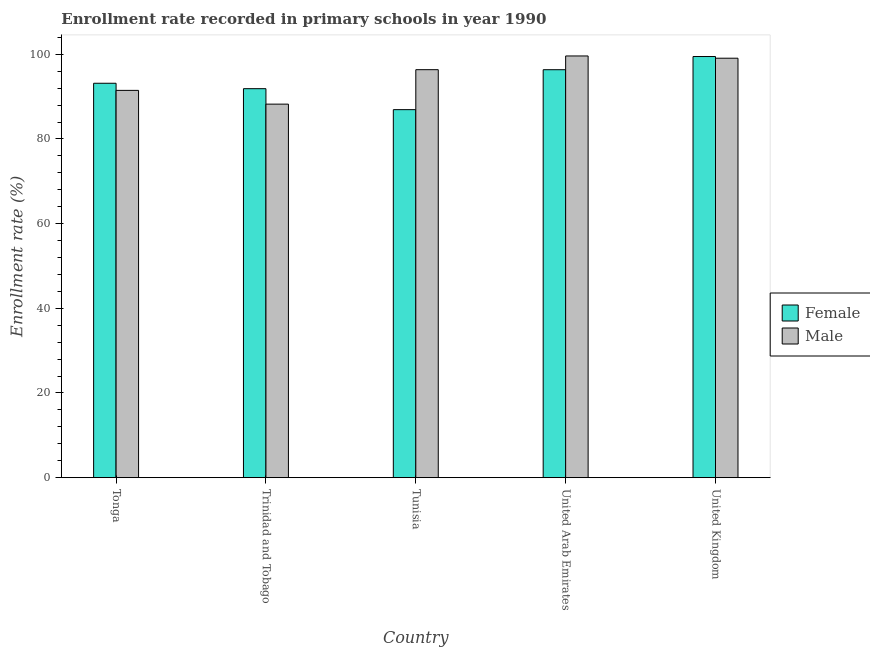How many different coloured bars are there?
Your answer should be very brief. 2. How many groups of bars are there?
Make the answer very short. 5. Are the number of bars per tick equal to the number of legend labels?
Offer a terse response. Yes. Are the number of bars on each tick of the X-axis equal?
Keep it short and to the point. Yes. How many bars are there on the 4th tick from the left?
Offer a very short reply. 2. What is the label of the 3rd group of bars from the left?
Provide a short and direct response. Tunisia. What is the enrollment rate of male students in Trinidad and Tobago?
Provide a succinct answer. 88.24. Across all countries, what is the maximum enrollment rate of male students?
Keep it short and to the point. 99.62. Across all countries, what is the minimum enrollment rate of female students?
Offer a terse response. 86.93. In which country was the enrollment rate of female students maximum?
Your response must be concise. United Kingdom. In which country was the enrollment rate of female students minimum?
Your answer should be compact. Tunisia. What is the total enrollment rate of female students in the graph?
Your response must be concise. 467.84. What is the difference between the enrollment rate of male students in Trinidad and Tobago and that in Tunisia?
Your response must be concise. -8.14. What is the difference between the enrollment rate of male students in United Arab Emirates and the enrollment rate of female students in Trinidad and Tobago?
Keep it short and to the point. 7.73. What is the average enrollment rate of male students per country?
Ensure brevity in your answer.  94.96. What is the difference between the enrollment rate of female students and enrollment rate of male students in Tunisia?
Your answer should be compact. -9.44. What is the ratio of the enrollment rate of male students in Tunisia to that in United Kingdom?
Offer a terse response. 0.97. What is the difference between the highest and the second highest enrollment rate of female students?
Provide a short and direct response. 3.12. What is the difference between the highest and the lowest enrollment rate of female students?
Your answer should be very brief. 12.55. What does the 2nd bar from the right in United Arab Emirates represents?
Your response must be concise. Female. How many bars are there?
Make the answer very short. 10. Are all the bars in the graph horizontal?
Offer a terse response. No. Are the values on the major ticks of Y-axis written in scientific E-notation?
Your answer should be compact. No. Does the graph contain grids?
Ensure brevity in your answer.  No. What is the title of the graph?
Make the answer very short. Enrollment rate recorded in primary schools in year 1990. What is the label or title of the X-axis?
Keep it short and to the point. Country. What is the label or title of the Y-axis?
Your response must be concise. Enrollment rate (%). What is the Enrollment rate (%) in Female in Tonga?
Your answer should be very brief. 93.17. What is the Enrollment rate (%) of Male in Tonga?
Give a very brief answer. 91.48. What is the Enrollment rate (%) of Female in Trinidad and Tobago?
Offer a terse response. 91.89. What is the Enrollment rate (%) of Male in Trinidad and Tobago?
Offer a very short reply. 88.24. What is the Enrollment rate (%) in Female in Tunisia?
Your answer should be compact. 86.93. What is the Enrollment rate (%) of Male in Tunisia?
Your response must be concise. 96.37. What is the Enrollment rate (%) in Female in United Arab Emirates?
Keep it short and to the point. 96.37. What is the Enrollment rate (%) of Male in United Arab Emirates?
Your answer should be very brief. 99.62. What is the Enrollment rate (%) in Female in United Kingdom?
Offer a very short reply. 99.48. What is the Enrollment rate (%) in Male in United Kingdom?
Give a very brief answer. 99.08. Across all countries, what is the maximum Enrollment rate (%) in Female?
Your answer should be compact. 99.48. Across all countries, what is the maximum Enrollment rate (%) in Male?
Give a very brief answer. 99.62. Across all countries, what is the minimum Enrollment rate (%) in Female?
Offer a terse response. 86.93. Across all countries, what is the minimum Enrollment rate (%) of Male?
Your answer should be compact. 88.24. What is the total Enrollment rate (%) of Female in the graph?
Your answer should be very brief. 467.83. What is the total Enrollment rate (%) in Male in the graph?
Your answer should be very brief. 474.79. What is the difference between the Enrollment rate (%) in Female in Tonga and that in Trinidad and Tobago?
Your response must be concise. 1.28. What is the difference between the Enrollment rate (%) in Male in Tonga and that in Trinidad and Tobago?
Keep it short and to the point. 3.25. What is the difference between the Enrollment rate (%) of Female in Tonga and that in Tunisia?
Give a very brief answer. 6.23. What is the difference between the Enrollment rate (%) in Male in Tonga and that in Tunisia?
Provide a succinct answer. -4.89. What is the difference between the Enrollment rate (%) in Female in Tonga and that in United Arab Emirates?
Provide a succinct answer. -3.2. What is the difference between the Enrollment rate (%) in Male in Tonga and that in United Arab Emirates?
Your response must be concise. -8.13. What is the difference between the Enrollment rate (%) in Female in Tonga and that in United Kingdom?
Provide a succinct answer. -6.32. What is the difference between the Enrollment rate (%) in Male in Tonga and that in United Kingdom?
Your answer should be very brief. -7.6. What is the difference between the Enrollment rate (%) of Female in Trinidad and Tobago and that in Tunisia?
Your response must be concise. 4.95. What is the difference between the Enrollment rate (%) in Male in Trinidad and Tobago and that in Tunisia?
Give a very brief answer. -8.14. What is the difference between the Enrollment rate (%) of Female in Trinidad and Tobago and that in United Arab Emirates?
Offer a terse response. -4.48. What is the difference between the Enrollment rate (%) in Male in Trinidad and Tobago and that in United Arab Emirates?
Your response must be concise. -11.38. What is the difference between the Enrollment rate (%) in Female in Trinidad and Tobago and that in United Kingdom?
Ensure brevity in your answer.  -7.6. What is the difference between the Enrollment rate (%) of Male in Trinidad and Tobago and that in United Kingdom?
Offer a very short reply. -10.85. What is the difference between the Enrollment rate (%) of Female in Tunisia and that in United Arab Emirates?
Your response must be concise. -9.44. What is the difference between the Enrollment rate (%) of Male in Tunisia and that in United Arab Emirates?
Your answer should be very brief. -3.24. What is the difference between the Enrollment rate (%) of Female in Tunisia and that in United Kingdom?
Give a very brief answer. -12.55. What is the difference between the Enrollment rate (%) of Male in Tunisia and that in United Kingdom?
Ensure brevity in your answer.  -2.71. What is the difference between the Enrollment rate (%) in Female in United Arab Emirates and that in United Kingdom?
Offer a terse response. -3.12. What is the difference between the Enrollment rate (%) in Male in United Arab Emirates and that in United Kingdom?
Your answer should be very brief. 0.53. What is the difference between the Enrollment rate (%) in Female in Tonga and the Enrollment rate (%) in Male in Trinidad and Tobago?
Provide a short and direct response. 4.93. What is the difference between the Enrollment rate (%) in Female in Tonga and the Enrollment rate (%) in Male in Tunisia?
Provide a succinct answer. -3.21. What is the difference between the Enrollment rate (%) of Female in Tonga and the Enrollment rate (%) of Male in United Arab Emirates?
Ensure brevity in your answer.  -6.45. What is the difference between the Enrollment rate (%) in Female in Tonga and the Enrollment rate (%) in Male in United Kingdom?
Your answer should be compact. -5.92. What is the difference between the Enrollment rate (%) of Female in Trinidad and Tobago and the Enrollment rate (%) of Male in Tunisia?
Your answer should be compact. -4.49. What is the difference between the Enrollment rate (%) of Female in Trinidad and Tobago and the Enrollment rate (%) of Male in United Arab Emirates?
Your answer should be very brief. -7.73. What is the difference between the Enrollment rate (%) of Female in Trinidad and Tobago and the Enrollment rate (%) of Male in United Kingdom?
Make the answer very short. -7.2. What is the difference between the Enrollment rate (%) of Female in Tunisia and the Enrollment rate (%) of Male in United Arab Emirates?
Ensure brevity in your answer.  -12.68. What is the difference between the Enrollment rate (%) of Female in Tunisia and the Enrollment rate (%) of Male in United Kingdom?
Provide a succinct answer. -12.15. What is the difference between the Enrollment rate (%) of Female in United Arab Emirates and the Enrollment rate (%) of Male in United Kingdom?
Provide a short and direct response. -2.72. What is the average Enrollment rate (%) in Female per country?
Offer a terse response. 93.57. What is the average Enrollment rate (%) in Male per country?
Offer a terse response. 94.96. What is the difference between the Enrollment rate (%) in Female and Enrollment rate (%) in Male in Tonga?
Offer a very short reply. 1.68. What is the difference between the Enrollment rate (%) of Female and Enrollment rate (%) of Male in Trinidad and Tobago?
Offer a terse response. 3.65. What is the difference between the Enrollment rate (%) of Female and Enrollment rate (%) of Male in Tunisia?
Your answer should be compact. -9.44. What is the difference between the Enrollment rate (%) of Female and Enrollment rate (%) of Male in United Arab Emirates?
Make the answer very short. -3.25. What is the difference between the Enrollment rate (%) in Female and Enrollment rate (%) in Male in United Kingdom?
Make the answer very short. 0.4. What is the ratio of the Enrollment rate (%) in Female in Tonga to that in Trinidad and Tobago?
Ensure brevity in your answer.  1.01. What is the ratio of the Enrollment rate (%) in Male in Tonga to that in Trinidad and Tobago?
Ensure brevity in your answer.  1.04. What is the ratio of the Enrollment rate (%) in Female in Tonga to that in Tunisia?
Keep it short and to the point. 1.07. What is the ratio of the Enrollment rate (%) of Male in Tonga to that in Tunisia?
Give a very brief answer. 0.95. What is the ratio of the Enrollment rate (%) of Female in Tonga to that in United Arab Emirates?
Offer a very short reply. 0.97. What is the ratio of the Enrollment rate (%) in Male in Tonga to that in United Arab Emirates?
Offer a terse response. 0.92. What is the ratio of the Enrollment rate (%) in Female in Tonga to that in United Kingdom?
Your answer should be compact. 0.94. What is the ratio of the Enrollment rate (%) in Male in Tonga to that in United Kingdom?
Your answer should be very brief. 0.92. What is the ratio of the Enrollment rate (%) of Female in Trinidad and Tobago to that in Tunisia?
Provide a short and direct response. 1.06. What is the ratio of the Enrollment rate (%) of Male in Trinidad and Tobago to that in Tunisia?
Provide a short and direct response. 0.92. What is the ratio of the Enrollment rate (%) in Female in Trinidad and Tobago to that in United Arab Emirates?
Keep it short and to the point. 0.95. What is the ratio of the Enrollment rate (%) of Male in Trinidad and Tobago to that in United Arab Emirates?
Offer a very short reply. 0.89. What is the ratio of the Enrollment rate (%) of Female in Trinidad and Tobago to that in United Kingdom?
Provide a succinct answer. 0.92. What is the ratio of the Enrollment rate (%) in Male in Trinidad and Tobago to that in United Kingdom?
Provide a short and direct response. 0.89. What is the ratio of the Enrollment rate (%) in Female in Tunisia to that in United Arab Emirates?
Provide a short and direct response. 0.9. What is the ratio of the Enrollment rate (%) of Male in Tunisia to that in United Arab Emirates?
Offer a terse response. 0.97. What is the ratio of the Enrollment rate (%) of Female in Tunisia to that in United Kingdom?
Offer a very short reply. 0.87. What is the ratio of the Enrollment rate (%) of Male in Tunisia to that in United Kingdom?
Provide a short and direct response. 0.97. What is the ratio of the Enrollment rate (%) in Female in United Arab Emirates to that in United Kingdom?
Provide a succinct answer. 0.97. What is the ratio of the Enrollment rate (%) of Male in United Arab Emirates to that in United Kingdom?
Your response must be concise. 1.01. What is the difference between the highest and the second highest Enrollment rate (%) of Female?
Make the answer very short. 3.12. What is the difference between the highest and the second highest Enrollment rate (%) in Male?
Offer a terse response. 0.53. What is the difference between the highest and the lowest Enrollment rate (%) in Female?
Ensure brevity in your answer.  12.55. What is the difference between the highest and the lowest Enrollment rate (%) of Male?
Give a very brief answer. 11.38. 